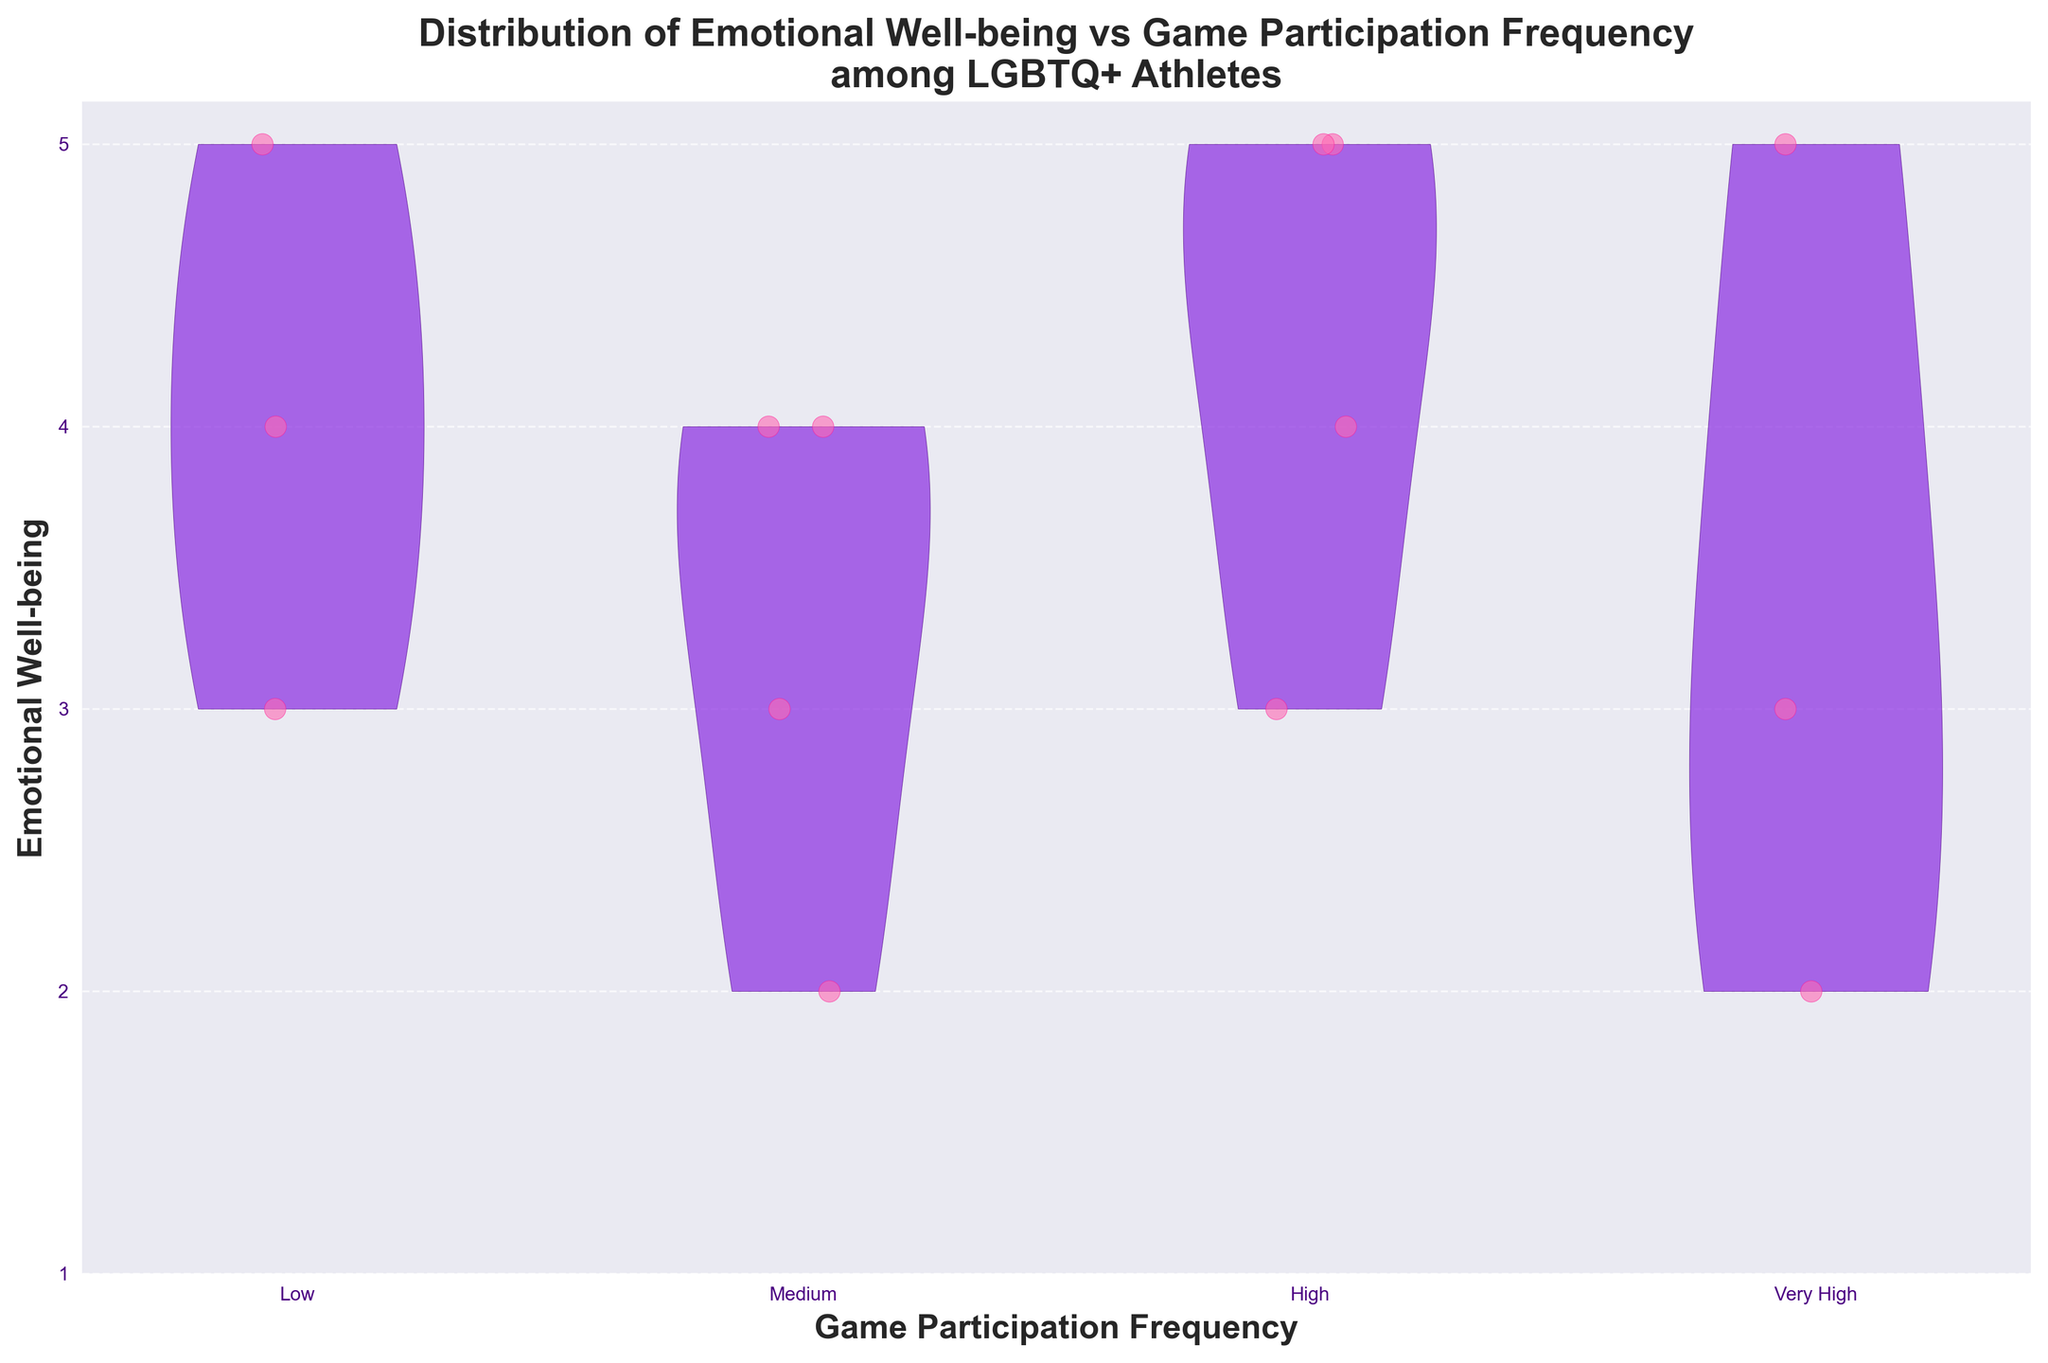What is the title of the figure? The title is found at the top of the figure, and it gives a quick summary of what the figure represents.
Answer: Distribution of Emotional Well-being vs Game Participation Frequency among LGBTQ+ Athletes Which axis represents the Game Participation Frequency? The x-axis (horizontal axis) represents the Game Participation Frequency, as indicated by the label below it.
Answer: x-axis What color is used for the violin plot bodies? The bodies of the violin plots are colored using shades of purple, which can be identified visually.
Answer: Purple How many data points are there for athletes with a "Very High" Game Participation Frequency? Count the number of jittered points (scattered dots) under the "Very High" category on the x-axis.
Answer: 3 How does the median Emotional Well-being in the "Low" Game Participation Frequency group compare to the "Very High" group? Visually estimate the median (central tendency) within the violin plots, noting the differences. Median Emotional Well-being seems higher in "Very High" compared to "Low."
Answer: Higher in "Very High" What are the Emotional Well-being values for athletes with a Medium Game Participation Frequency? Look at the y-axis values for jittered points under the "Medium" x-axis label.
Answer: 2, 3, 4 What is the range of Emotional Well-being values for "High" Game Participation Frequency? Determine the minimum and maximum y-axis values that jittered points achieve under the "High" category.
Answer: 3 to 5 What is the mode of Emotional Well-being values for athletes with "Very High" Game Participation Frequency? Identify the most frequently occurring Emotional Well-being value from the jittered points under the "Very High" label.
Answer: 5 How does the distribution of Emotional Well-being in the "Medium" group differ from the "Low" group? Compare the shapes and spread of the violin plots for the "Medium" and "Low" categories; observe the concentration and spread of points.
Answer: The "Medium" group has a broader range and higher concentration around the middle values than the "Low" group Which group exhibits the widest spread of Emotional Well-being values? Look at the width and distribution in the violin plots for each group; the group with the largest variance of datapoints indicates the widest spread.
Answer: High 